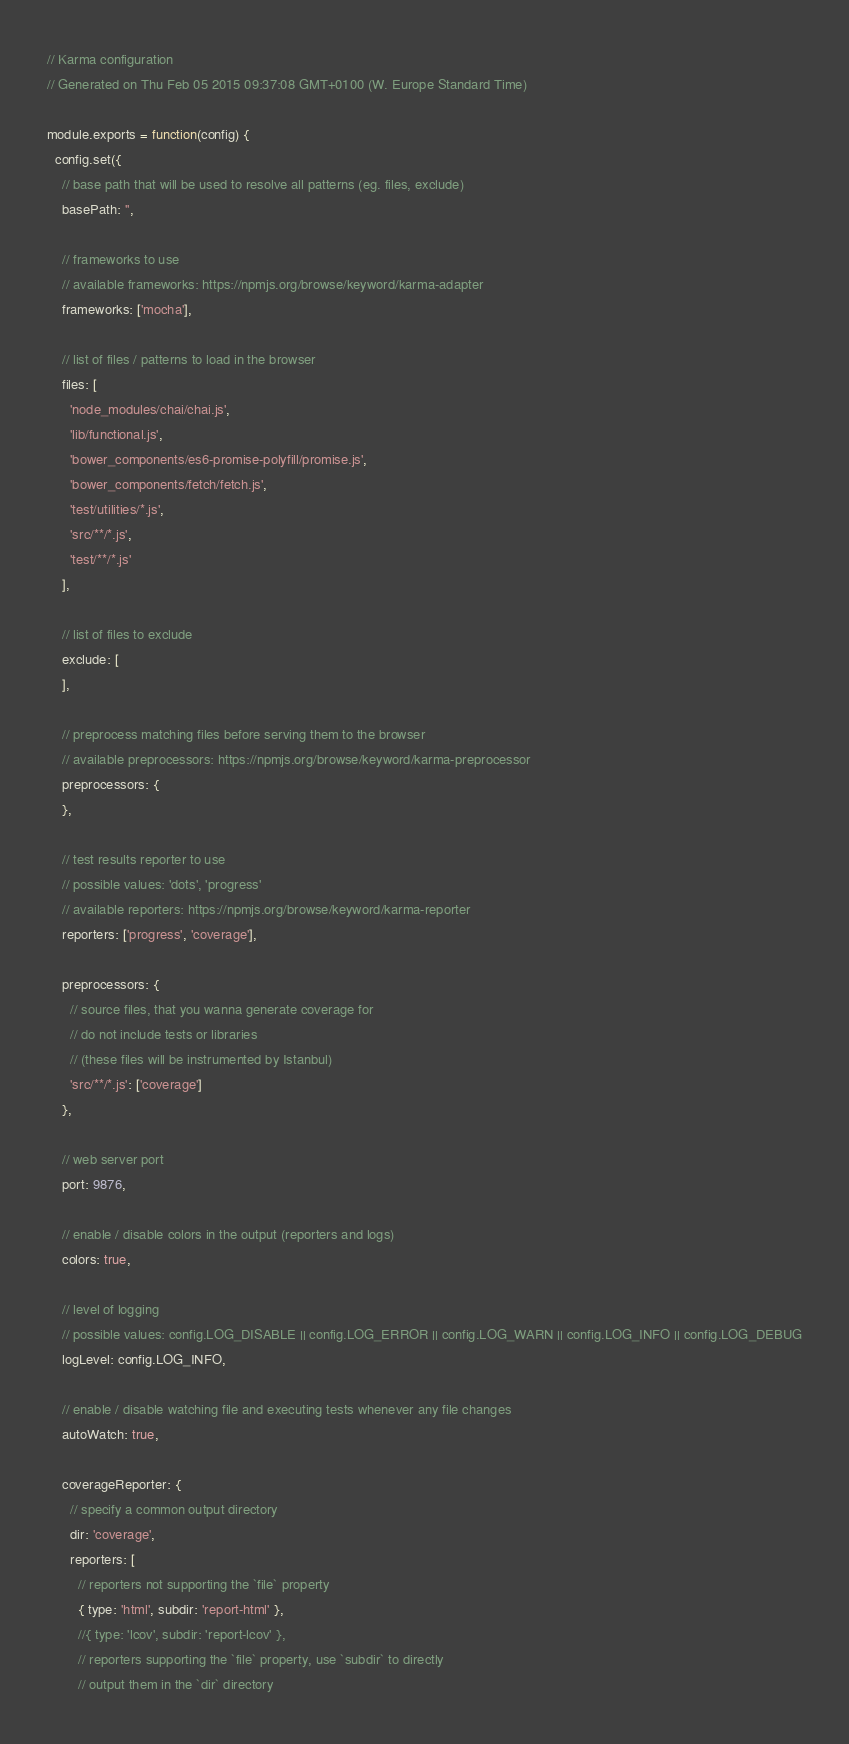Convert code to text. <code><loc_0><loc_0><loc_500><loc_500><_JavaScript_>// Karma configuration
// Generated on Thu Feb 05 2015 09:37:08 GMT+0100 (W. Europe Standard Time)

module.exports = function(config) {
  config.set({
    // base path that will be used to resolve all patterns (eg. files, exclude)
    basePath: '',

    // frameworks to use
    // available frameworks: https://npmjs.org/browse/keyword/karma-adapter
    frameworks: ['mocha'],

    // list of files / patterns to load in the browser
    files: [
      'node_modules/chai/chai.js',
      'lib/functional.js',
      'bower_components/es6-promise-polyfill/promise.js',
      'bower_components/fetch/fetch.js',
      'test/utilities/*.js',
      'src/**/*.js',
      'test/**/*.js'
    ],

    // list of files to exclude
    exclude: [
    ],

    // preprocess matching files before serving them to the browser
    // available preprocessors: https://npmjs.org/browse/keyword/karma-preprocessor
    preprocessors: {
    },

    // test results reporter to use
    // possible values: 'dots', 'progress'
    // available reporters: https://npmjs.org/browse/keyword/karma-reporter
    reporters: ['progress', 'coverage'],

    preprocessors: {
      // source files, that you wanna generate coverage for
      // do not include tests or libraries
      // (these files will be instrumented by Istanbul)
      'src/**/*.js': ['coverage']
    },

    // web server port
    port: 9876,

    // enable / disable colors in the output (reporters and logs)
    colors: true,

    // level of logging
    // possible values: config.LOG_DISABLE || config.LOG_ERROR || config.LOG_WARN || config.LOG_INFO || config.LOG_DEBUG
    logLevel: config.LOG_INFO,

    // enable / disable watching file and executing tests whenever any file changes
    autoWatch: true,

    coverageReporter: {
      // specify a common output directory
      dir: 'coverage',
      reporters: [
        // reporters not supporting the `file` property
        { type: 'html', subdir: 'report-html' },
        //{ type: 'lcov', subdir: 'report-lcov' },
        // reporters supporting the `file` property, use `subdir` to directly
        // output them in the `dir` directory</code> 